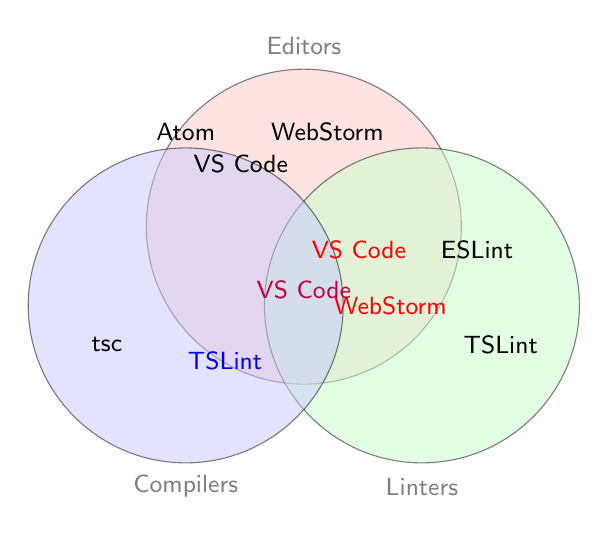What are the three categories shown in the diagram? The three categories are represented by three circles. Each circle is labeled with a category: "Editors," "Linters," and "Compilers."
Answer: Editors, Linters, Compilers Which tools are found only in the Editors category? Tools in the Editors category alone are inside the "Editors" circle and not overlapping with others. These tools are Visual Studio Code, WebStorm, and Atom.
Answer: Visual Studio Code, WebStorm, Atom Which tool is shared by all three categories? The tool shared by all three categories is located at the intersection of all three circles. It is "VS Code".
Answer: VS Code What's the position of "TSLint" in relation to the categories? "TSLint" is found twice, once in the "Linters" category and once in the intersection of "Linters" and "Compilers."
Answer: Linters and Linters & Compilers Which tool overlaps between Editors and Linters but not Compilers? Identify the tool in the intersection area between "Editors" and "Linters" only. The tool is "WebStorm."
Answer: WebStorm Which categories do linters cover based on the diagram? Look at the circle labeled "Linters" and its overlaps. Linters cover "Linters," "Editors & Linters," "Linters & Compilers," and "Editors, Linters & Compilers."
Answer: Linters, Editors & Linters, Linters & Compilers, Editors, Linters & Compilers How many tools fall under the Linters category? Count the tools within the "Linters" circle and its intersections. The tools are ESLint, TSLint (twice), and VS Code (twice).
Answer: 5 Is "tsc" overlapping with any other categories? Check the position of "tsc" within the diagram. It lies solely in the "Compilers" category and does not overlap with other circles.
Answer: No Which tools are included in the overlapping area of Editors and Compilers? This is the shared region between "Editors" and "Compilers." The tools are Visual Studio Code and WebStorm.
Answer: Visual Studio Code, WebStorm 